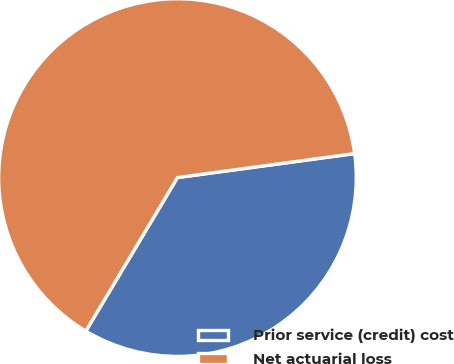Convert chart. <chart><loc_0><loc_0><loc_500><loc_500><pie_chart><fcel>Prior service (credit) cost<fcel>Net actuarial loss<nl><fcel>35.71%<fcel>64.29%<nl></chart> 